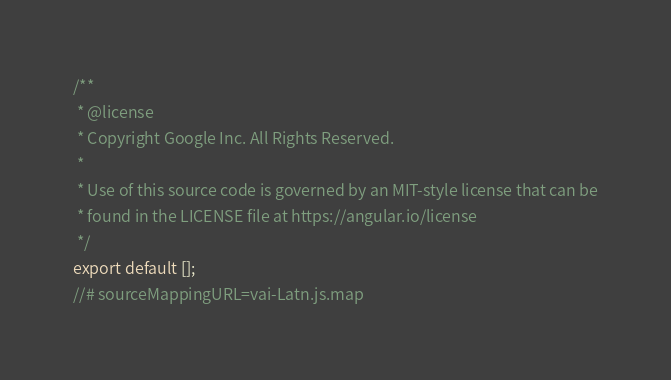<code> <loc_0><loc_0><loc_500><loc_500><_JavaScript_>/**
 * @license
 * Copyright Google Inc. All Rights Reserved.
 *
 * Use of this source code is governed by an MIT-style license that can be
 * found in the LICENSE file at https://angular.io/license
 */
export default [];
//# sourceMappingURL=vai-Latn.js.map</code> 